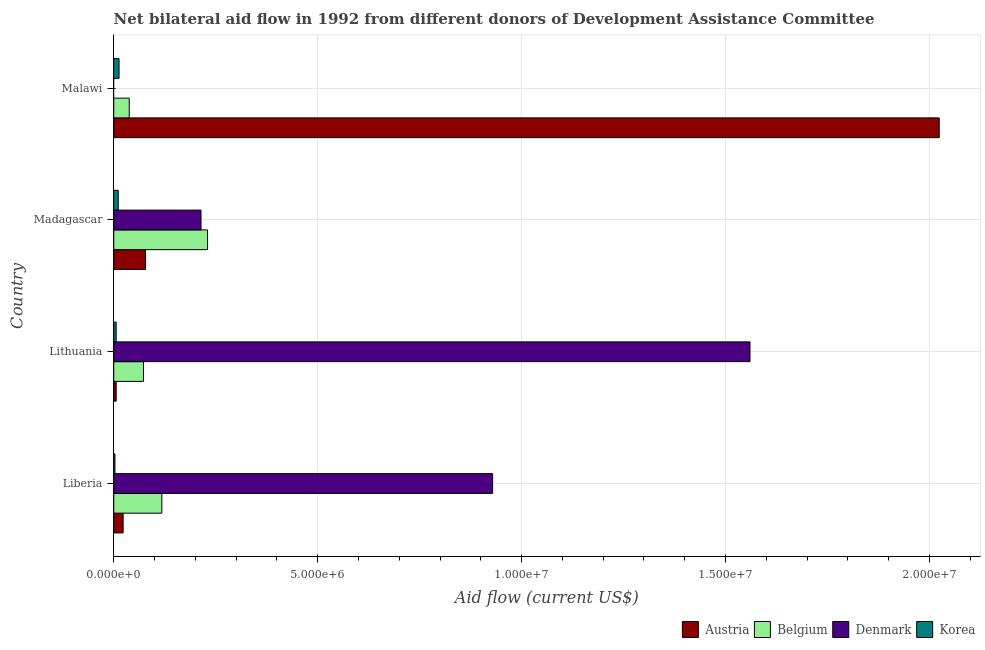How many groups of bars are there?
Offer a very short reply. 4. Are the number of bars on each tick of the Y-axis equal?
Keep it short and to the point. No. What is the label of the 1st group of bars from the top?
Provide a short and direct response. Malawi. What is the amount of aid given by korea in Liberia?
Offer a terse response. 3.00e+04. Across all countries, what is the maximum amount of aid given by belgium?
Make the answer very short. 2.30e+06. Across all countries, what is the minimum amount of aid given by belgium?
Ensure brevity in your answer.  3.80e+05. In which country was the amount of aid given by korea maximum?
Offer a very short reply. Malawi. What is the total amount of aid given by austria in the graph?
Give a very brief answer. 2.13e+07. What is the difference between the amount of aid given by denmark in Liberia and that in Lithuania?
Offer a very short reply. -6.31e+06. What is the difference between the amount of aid given by austria in Lithuania and the amount of aid given by denmark in Malawi?
Ensure brevity in your answer.  6.00e+04. What is the average amount of aid given by korea per country?
Provide a succinct answer. 8.25e+04. What is the difference between the amount of aid given by belgium and amount of aid given by denmark in Liberia?
Give a very brief answer. -8.11e+06. What is the ratio of the amount of aid given by denmark in Lithuania to that in Madagascar?
Provide a short and direct response. 7.29. What is the difference between the highest and the second highest amount of aid given by korea?
Give a very brief answer. 2.00e+04. What is the difference between the highest and the lowest amount of aid given by denmark?
Your answer should be very brief. 1.56e+07. Is the sum of the amount of aid given by austria in Lithuania and Madagascar greater than the maximum amount of aid given by belgium across all countries?
Offer a very short reply. No. How many bars are there?
Provide a short and direct response. 15. Are all the bars in the graph horizontal?
Offer a terse response. Yes. Are the values on the major ticks of X-axis written in scientific E-notation?
Keep it short and to the point. Yes. Does the graph contain any zero values?
Ensure brevity in your answer.  Yes. Where does the legend appear in the graph?
Keep it short and to the point. Bottom right. What is the title of the graph?
Provide a succinct answer. Net bilateral aid flow in 1992 from different donors of Development Assistance Committee. What is the label or title of the Y-axis?
Ensure brevity in your answer.  Country. What is the Aid flow (current US$) in Belgium in Liberia?
Offer a very short reply. 1.18e+06. What is the Aid flow (current US$) of Denmark in Liberia?
Offer a terse response. 9.29e+06. What is the Aid flow (current US$) of Austria in Lithuania?
Provide a succinct answer. 6.00e+04. What is the Aid flow (current US$) of Belgium in Lithuania?
Ensure brevity in your answer.  7.30e+05. What is the Aid flow (current US$) in Denmark in Lithuania?
Your answer should be very brief. 1.56e+07. What is the Aid flow (current US$) of Korea in Lithuania?
Give a very brief answer. 6.00e+04. What is the Aid flow (current US$) of Austria in Madagascar?
Offer a terse response. 7.80e+05. What is the Aid flow (current US$) in Belgium in Madagascar?
Your response must be concise. 2.30e+06. What is the Aid flow (current US$) in Denmark in Madagascar?
Make the answer very short. 2.14e+06. What is the Aid flow (current US$) of Austria in Malawi?
Give a very brief answer. 2.02e+07. What is the Aid flow (current US$) of Belgium in Malawi?
Your answer should be very brief. 3.80e+05. Across all countries, what is the maximum Aid flow (current US$) in Austria?
Give a very brief answer. 2.02e+07. Across all countries, what is the maximum Aid flow (current US$) in Belgium?
Your answer should be compact. 2.30e+06. Across all countries, what is the maximum Aid flow (current US$) of Denmark?
Make the answer very short. 1.56e+07. Across all countries, what is the minimum Aid flow (current US$) in Austria?
Make the answer very short. 6.00e+04. What is the total Aid flow (current US$) of Austria in the graph?
Keep it short and to the point. 2.13e+07. What is the total Aid flow (current US$) in Belgium in the graph?
Provide a succinct answer. 4.59e+06. What is the total Aid flow (current US$) in Denmark in the graph?
Offer a very short reply. 2.70e+07. What is the difference between the Aid flow (current US$) in Austria in Liberia and that in Lithuania?
Give a very brief answer. 1.70e+05. What is the difference between the Aid flow (current US$) of Denmark in Liberia and that in Lithuania?
Keep it short and to the point. -6.31e+06. What is the difference between the Aid flow (current US$) in Korea in Liberia and that in Lithuania?
Provide a short and direct response. -3.00e+04. What is the difference between the Aid flow (current US$) of Austria in Liberia and that in Madagascar?
Your answer should be very brief. -5.50e+05. What is the difference between the Aid flow (current US$) in Belgium in Liberia and that in Madagascar?
Provide a short and direct response. -1.12e+06. What is the difference between the Aid flow (current US$) of Denmark in Liberia and that in Madagascar?
Keep it short and to the point. 7.15e+06. What is the difference between the Aid flow (current US$) in Austria in Liberia and that in Malawi?
Provide a short and direct response. -2.00e+07. What is the difference between the Aid flow (current US$) in Belgium in Liberia and that in Malawi?
Your answer should be very brief. 8.00e+05. What is the difference between the Aid flow (current US$) in Austria in Lithuania and that in Madagascar?
Keep it short and to the point. -7.20e+05. What is the difference between the Aid flow (current US$) in Belgium in Lithuania and that in Madagascar?
Your answer should be very brief. -1.57e+06. What is the difference between the Aid flow (current US$) in Denmark in Lithuania and that in Madagascar?
Offer a terse response. 1.35e+07. What is the difference between the Aid flow (current US$) of Korea in Lithuania and that in Madagascar?
Provide a short and direct response. -5.00e+04. What is the difference between the Aid flow (current US$) in Austria in Lithuania and that in Malawi?
Provide a short and direct response. -2.02e+07. What is the difference between the Aid flow (current US$) of Belgium in Lithuania and that in Malawi?
Your response must be concise. 3.50e+05. What is the difference between the Aid flow (current US$) in Austria in Madagascar and that in Malawi?
Your response must be concise. -1.95e+07. What is the difference between the Aid flow (current US$) in Belgium in Madagascar and that in Malawi?
Keep it short and to the point. 1.92e+06. What is the difference between the Aid flow (current US$) in Korea in Madagascar and that in Malawi?
Keep it short and to the point. -2.00e+04. What is the difference between the Aid flow (current US$) of Austria in Liberia and the Aid flow (current US$) of Belgium in Lithuania?
Your answer should be very brief. -5.00e+05. What is the difference between the Aid flow (current US$) of Austria in Liberia and the Aid flow (current US$) of Denmark in Lithuania?
Provide a succinct answer. -1.54e+07. What is the difference between the Aid flow (current US$) of Austria in Liberia and the Aid flow (current US$) of Korea in Lithuania?
Your answer should be compact. 1.70e+05. What is the difference between the Aid flow (current US$) in Belgium in Liberia and the Aid flow (current US$) in Denmark in Lithuania?
Ensure brevity in your answer.  -1.44e+07. What is the difference between the Aid flow (current US$) in Belgium in Liberia and the Aid flow (current US$) in Korea in Lithuania?
Make the answer very short. 1.12e+06. What is the difference between the Aid flow (current US$) of Denmark in Liberia and the Aid flow (current US$) of Korea in Lithuania?
Ensure brevity in your answer.  9.23e+06. What is the difference between the Aid flow (current US$) of Austria in Liberia and the Aid flow (current US$) of Belgium in Madagascar?
Your response must be concise. -2.07e+06. What is the difference between the Aid flow (current US$) of Austria in Liberia and the Aid flow (current US$) of Denmark in Madagascar?
Offer a very short reply. -1.91e+06. What is the difference between the Aid flow (current US$) in Austria in Liberia and the Aid flow (current US$) in Korea in Madagascar?
Ensure brevity in your answer.  1.20e+05. What is the difference between the Aid flow (current US$) in Belgium in Liberia and the Aid flow (current US$) in Denmark in Madagascar?
Make the answer very short. -9.60e+05. What is the difference between the Aid flow (current US$) in Belgium in Liberia and the Aid flow (current US$) in Korea in Madagascar?
Make the answer very short. 1.07e+06. What is the difference between the Aid flow (current US$) in Denmark in Liberia and the Aid flow (current US$) in Korea in Madagascar?
Provide a succinct answer. 9.18e+06. What is the difference between the Aid flow (current US$) of Austria in Liberia and the Aid flow (current US$) of Belgium in Malawi?
Your answer should be compact. -1.50e+05. What is the difference between the Aid flow (current US$) of Austria in Liberia and the Aid flow (current US$) of Korea in Malawi?
Your answer should be compact. 1.00e+05. What is the difference between the Aid flow (current US$) in Belgium in Liberia and the Aid flow (current US$) in Korea in Malawi?
Provide a succinct answer. 1.05e+06. What is the difference between the Aid flow (current US$) in Denmark in Liberia and the Aid flow (current US$) in Korea in Malawi?
Offer a very short reply. 9.16e+06. What is the difference between the Aid flow (current US$) of Austria in Lithuania and the Aid flow (current US$) of Belgium in Madagascar?
Provide a short and direct response. -2.24e+06. What is the difference between the Aid flow (current US$) in Austria in Lithuania and the Aid flow (current US$) in Denmark in Madagascar?
Offer a very short reply. -2.08e+06. What is the difference between the Aid flow (current US$) of Austria in Lithuania and the Aid flow (current US$) of Korea in Madagascar?
Keep it short and to the point. -5.00e+04. What is the difference between the Aid flow (current US$) of Belgium in Lithuania and the Aid flow (current US$) of Denmark in Madagascar?
Your response must be concise. -1.41e+06. What is the difference between the Aid flow (current US$) of Belgium in Lithuania and the Aid flow (current US$) of Korea in Madagascar?
Your response must be concise. 6.20e+05. What is the difference between the Aid flow (current US$) in Denmark in Lithuania and the Aid flow (current US$) in Korea in Madagascar?
Ensure brevity in your answer.  1.55e+07. What is the difference between the Aid flow (current US$) of Austria in Lithuania and the Aid flow (current US$) of Belgium in Malawi?
Provide a succinct answer. -3.20e+05. What is the difference between the Aid flow (current US$) in Denmark in Lithuania and the Aid flow (current US$) in Korea in Malawi?
Your answer should be compact. 1.55e+07. What is the difference between the Aid flow (current US$) in Austria in Madagascar and the Aid flow (current US$) in Belgium in Malawi?
Offer a very short reply. 4.00e+05. What is the difference between the Aid flow (current US$) in Austria in Madagascar and the Aid flow (current US$) in Korea in Malawi?
Offer a very short reply. 6.50e+05. What is the difference between the Aid flow (current US$) of Belgium in Madagascar and the Aid flow (current US$) of Korea in Malawi?
Provide a short and direct response. 2.17e+06. What is the difference between the Aid flow (current US$) in Denmark in Madagascar and the Aid flow (current US$) in Korea in Malawi?
Your answer should be compact. 2.01e+06. What is the average Aid flow (current US$) in Austria per country?
Make the answer very short. 5.33e+06. What is the average Aid flow (current US$) in Belgium per country?
Ensure brevity in your answer.  1.15e+06. What is the average Aid flow (current US$) in Denmark per country?
Your answer should be compact. 6.76e+06. What is the average Aid flow (current US$) of Korea per country?
Keep it short and to the point. 8.25e+04. What is the difference between the Aid flow (current US$) in Austria and Aid flow (current US$) in Belgium in Liberia?
Make the answer very short. -9.50e+05. What is the difference between the Aid flow (current US$) in Austria and Aid flow (current US$) in Denmark in Liberia?
Keep it short and to the point. -9.06e+06. What is the difference between the Aid flow (current US$) in Belgium and Aid flow (current US$) in Denmark in Liberia?
Provide a succinct answer. -8.11e+06. What is the difference between the Aid flow (current US$) in Belgium and Aid flow (current US$) in Korea in Liberia?
Your answer should be very brief. 1.15e+06. What is the difference between the Aid flow (current US$) of Denmark and Aid flow (current US$) of Korea in Liberia?
Keep it short and to the point. 9.26e+06. What is the difference between the Aid flow (current US$) in Austria and Aid flow (current US$) in Belgium in Lithuania?
Provide a succinct answer. -6.70e+05. What is the difference between the Aid flow (current US$) in Austria and Aid flow (current US$) in Denmark in Lithuania?
Make the answer very short. -1.55e+07. What is the difference between the Aid flow (current US$) in Austria and Aid flow (current US$) in Korea in Lithuania?
Ensure brevity in your answer.  0. What is the difference between the Aid flow (current US$) in Belgium and Aid flow (current US$) in Denmark in Lithuania?
Make the answer very short. -1.49e+07. What is the difference between the Aid flow (current US$) in Belgium and Aid flow (current US$) in Korea in Lithuania?
Give a very brief answer. 6.70e+05. What is the difference between the Aid flow (current US$) of Denmark and Aid flow (current US$) of Korea in Lithuania?
Offer a very short reply. 1.55e+07. What is the difference between the Aid flow (current US$) in Austria and Aid flow (current US$) in Belgium in Madagascar?
Offer a very short reply. -1.52e+06. What is the difference between the Aid flow (current US$) of Austria and Aid flow (current US$) of Denmark in Madagascar?
Your response must be concise. -1.36e+06. What is the difference between the Aid flow (current US$) in Austria and Aid flow (current US$) in Korea in Madagascar?
Offer a terse response. 6.70e+05. What is the difference between the Aid flow (current US$) in Belgium and Aid flow (current US$) in Denmark in Madagascar?
Offer a very short reply. 1.60e+05. What is the difference between the Aid flow (current US$) in Belgium and Aid flow (current US$) in Korea in Madagascar?
Ensure brevity in your answer.  2.19e+06. What is the difference between the Aid flow (current US$) in Denmark and Aid flow (current US$) in Korea in Madagascar?
Ensure brevity in your answer.  2.03e+06. What is the difference between the Aid flow (current US$) of Austria and Aid flow (current US$) of Belgium in Malawi?
Offer a very short reply. 1.99e+07. What is the difference between the Aid flow (current US$) in Austria and Aid flow (current US$) in Korea in Malawi?
Your answer should be very brief. 2.01e+07. What is the difference between the Aid flow (current US$) in Belgium and Aid flow (current US$) in Korea in Malawi?
Your response must be concise. 2.50e+05. What is the ratio of the Aid flow (current US$) of Austria in Liberia to that in Lithuania?
Give a very brief answer. 3.83. What is the ratio of the Aid flow (current US$) of Belgium in Liberia to that in Lithuania?
Your answer should be very brief. 1.62. What is the ratio of the Aid flow (current US$) of Denmark in Liberia to that in Lithuania?
Your answer should be compact. 0.6. What is the ratio of the Aid flow (current US$) in Korea in Liberia to that in Lithuania?
Your response must be concise. 0.5. What is the ratio of the Aid flow (current US$) in Austria in Liberia to that in Madagascar?
Your response must be concise. 0.29. What is the ratio of the Aid flow (current US$) of Belgium in Liberia to that in Madagascar?
Ensure brevity in your answer.  0.51. What is the ratio of the Aid flow (current US$) of Denmark in Liberia to that in Madagascar?
Ensure brevity in your answer.  4.34. What is the ratio of the Aid flow (current US$) in Korea in Liberia to that in Madagascar?
Provide a succinct answer. 0.27. What is the ratio of the Aid flow (current US$) in Austria in Liberia to that in Malawi?
Make the answer very short. 0.01. What is the ratio of the Aid flow (current US$) of Belgium in Liberia to that in Malawi?
Offer a very short reply. 3.11. What is the ratio of the Aid flow (current US$) of Korea in Liberia to that in Malawi?
Give a very brief answer. 0.23. What is the ratio of the Aid flow (current US$) in Austria in Lithuania to that in Madagascar?
Offer a terse response. 0.08. What is the ratio of the Aid flow (current US$) in Belgium in Lithuania to that in Madagascar?
Make the answer very short. 0.32. What is the ratio of the Aid flow (current US$) in Denmark in Lithuania to that in Madagascar?
Provide a succinct answer. 7.29. What is the ratio of the Aid flow (current US$) of Korea in Lithuania to that in Madagascar?
Your response must be concise. 0.55. What is the ratio of the Aid flow (current US$) of Austria in Lithuania to that in Malawi?
Your answer should be compact. 0. What is the ratio of the Aid flow (current US$) of Belgium in Lithuania to that in Malawi?
Your answer should be compact. 1.92. What is the ratio of the Aid flow (current US$) in Korea in Lithuania to that in Malawi?
Keep it short and to the point. 0.46. What is the ratio of the Aid flow (current US$) in Austria in Madagascar to that in Malawi?
Give a very brief answer. 0.04. What is the ratio of the Aid flow (current US$) of Belgium in Madagascar to that in Malawi?
Provide a short and direct response. 6.05. What is the ratio of the Aid flow (current US$) of Korea in Madagascar to that in Malawi?
Offer a very short reply. 0.85. What is the difference between the highest and the second highest Aid flow (current US$) in Austria?
Give a very brief answer. 1.95e+07. What is the difference between the highest and the second highest Aid flow (current US$) of Belgium?
Ensure brevity in your answer.  1.12e+06. What is the difference between the highest and the second highest Aid flow (current US$) in Denmark?
Offer a terse response. 6.31e+06. What is the difference between the highest and the second highest Aid flow (current US$) of Korea?
Ensure brevity in your answer.  2.00e+04. What is the difference between the highest and the lowest Aid flow (current US$) in Austria?
Your answer should be very brief. 2.02e+07. What is the difference between the highest and the lowest Aid flow (current US$) in Belgium?
Your answer should be compact. 1.92e+06. What is the difference between the highest and the lowest Aid flow (current US$) of Denmark?
Your answer should be compact. 1.56e+07. What is the difference between the highest and the lowest Aid flow (current US$) of Korea?
Provide a succinct answer. 1.00e+05. 